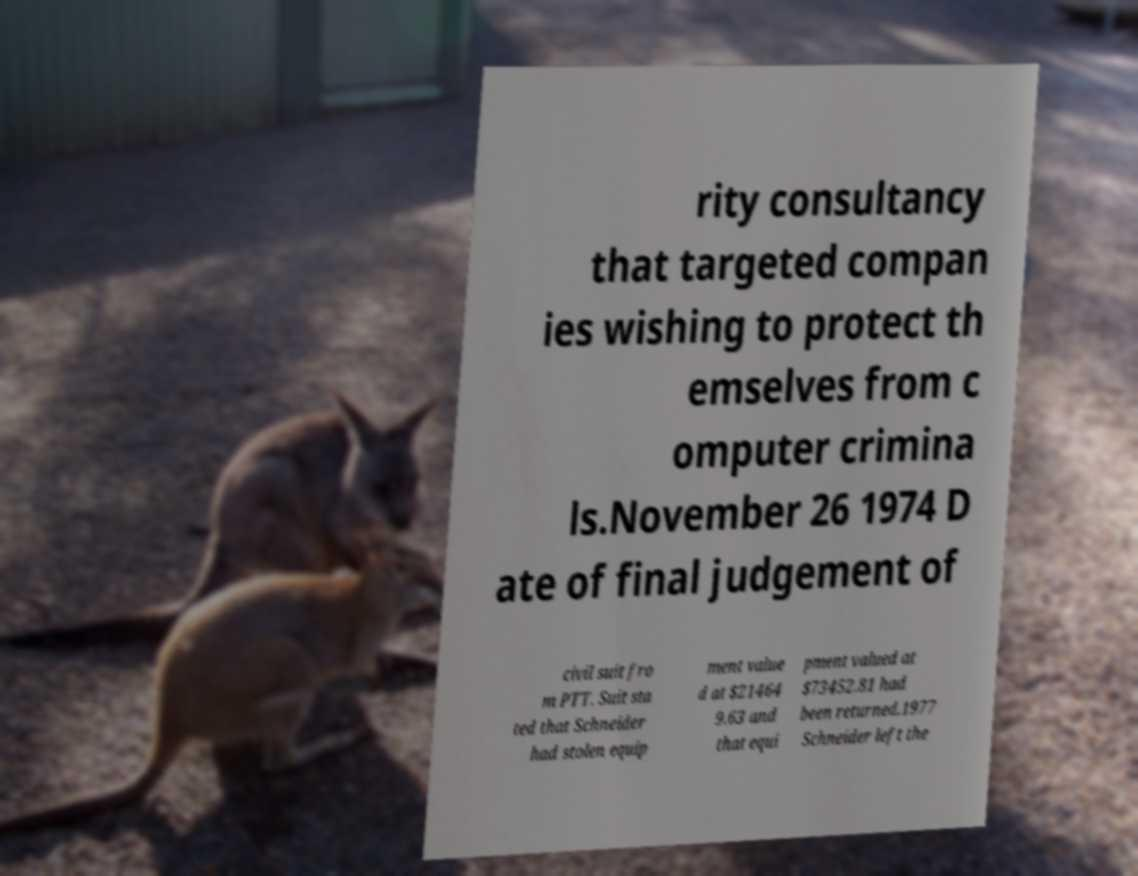Can you read and provide the text displayed in the image?This photo seems to have some interesting text. Can you extract and type it out for me? rity consultancy that targeted compan ies wishing to protect th emselves from c omputer crimina ls.November 26 1974 D ate of final judgement of civil suit fro m PTT. Suit sta ted that Schneider had stolen equip ment value d at $21464 9.63 and that equi pment valued at $73452.81 had been returned.1977 Schneider left the 